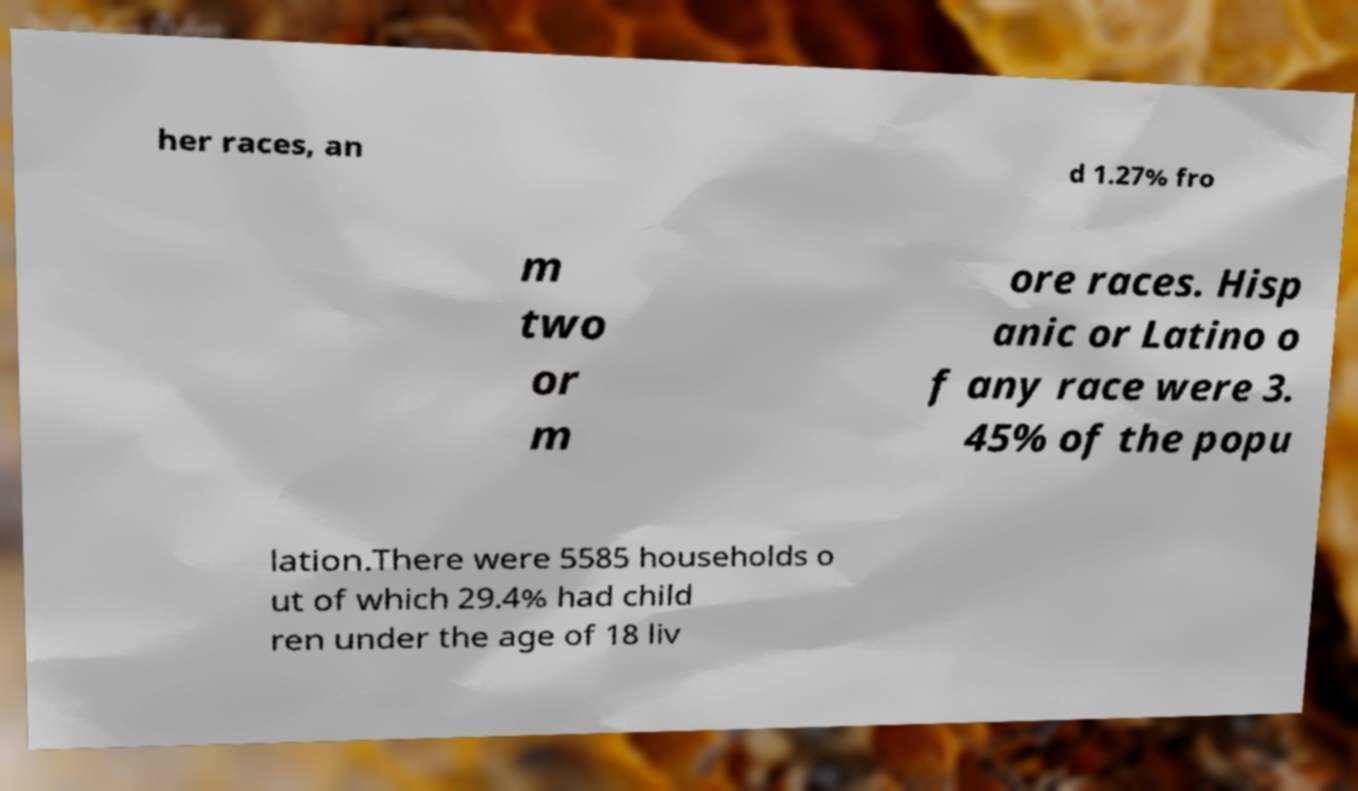Could you assist in decoding the text presented in this image and type it out clearly? her races, an d 1.27% fro m two or m ore races. Hisp anic or Latino o f any race were 3. 45% of the popu lation.There were 5585 households o ut of which 29.4% had child ren under the age of 18 liv 